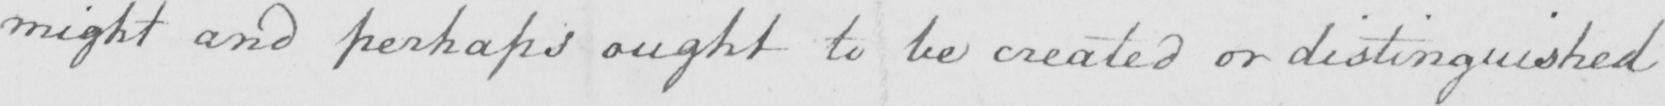Please transcribe the handwritten text in this image. might and perhaps ought to be created or distinguished 